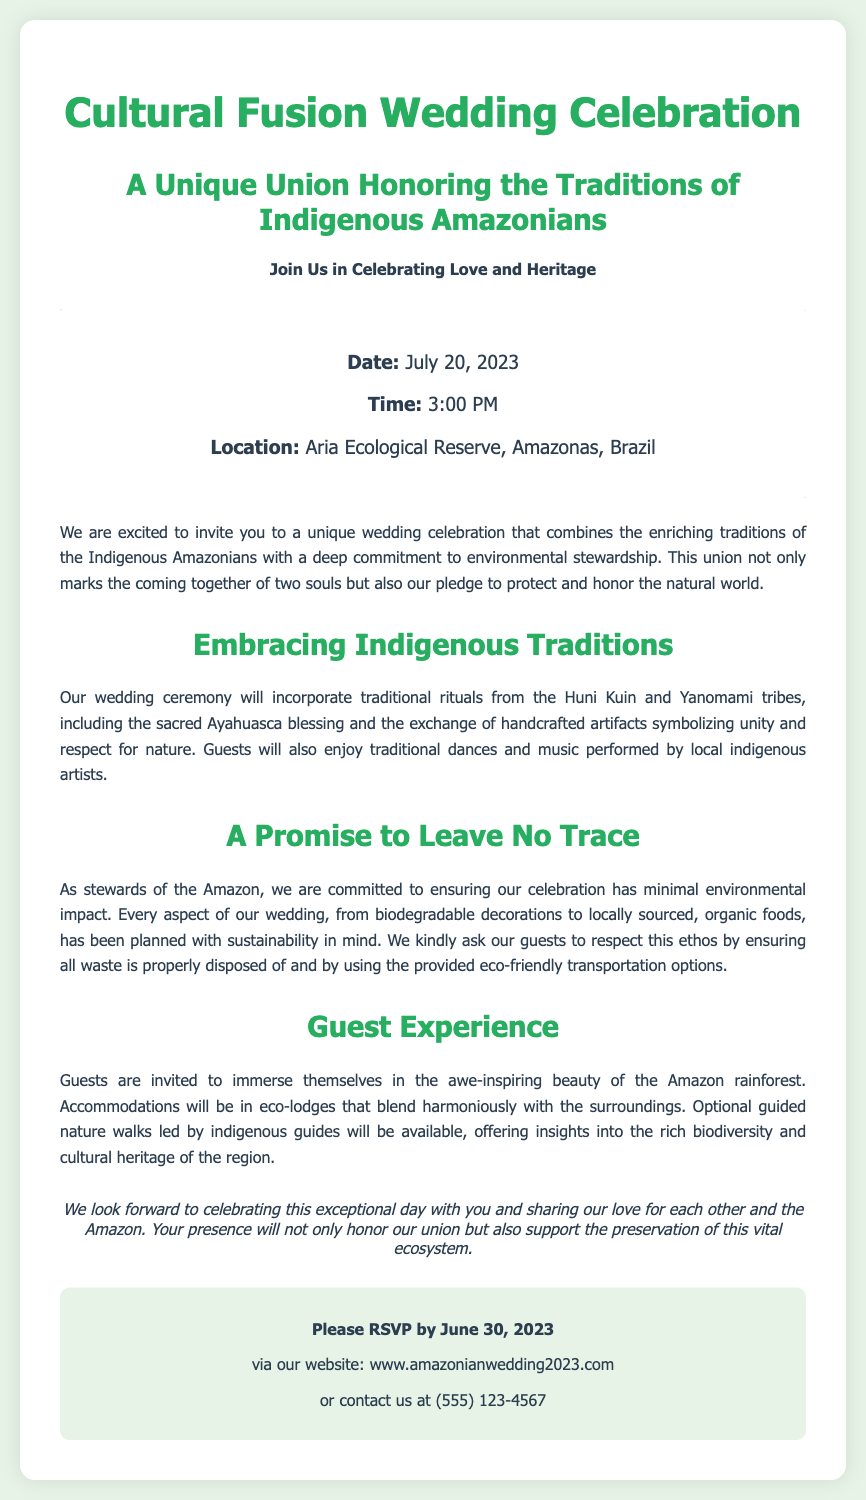what is the wedding date? The wedding date is explicitly stated in the document.
Answer: July 20, 2023 where is the wedding taking place? The location is provided in the document.
Answer: Aria Ecological Reserve, Amazonas, Brazil what commitment does the couple make regarding the environment? The document mentions a specific promise made by the couple.
Answer: Leave No Trace which tribes' traditions are incorporated into the wedding ceremony? The document explicitly names the tribes involved in the wedding traditions.
Answer: Huni Kuin and Yanomami what time does the wedding ceremony start? The starting time for the wedding ceremony is mentioned in the document.
Answer: 3:00 PM how should guests respond to the invitation? The document provides a method for guests to RSVP.
Answer: via our website what type of accommodations will guests have? The document describes the nature of accommodations for guests.
Answer: eco-lodges what is the purpose of the optional guided nature walks? The document outlines the purpose of these activities.
Answer: insights into the rich biodiversity and cultural heritage what should guests respect during the celebration? The document highlights a specific expectation from guests.
Answer: environmental stewardship 